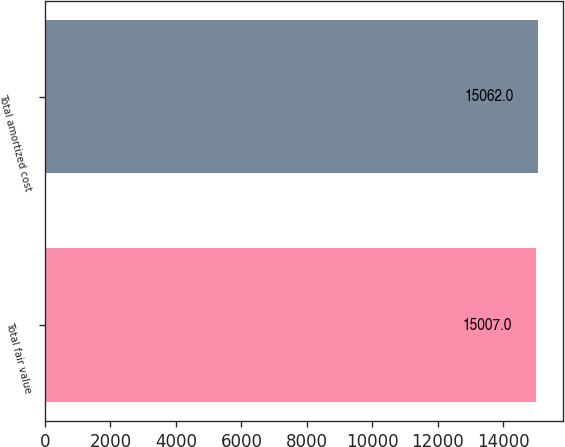Convert chart to OTSL. <chart><loc_0><loc_0><loc_500><loc_500><bar_chart><fcel>Total fair value<fcel>Total amortized cost<nl><fcel>15007<fcel>15062<nl></chart> 